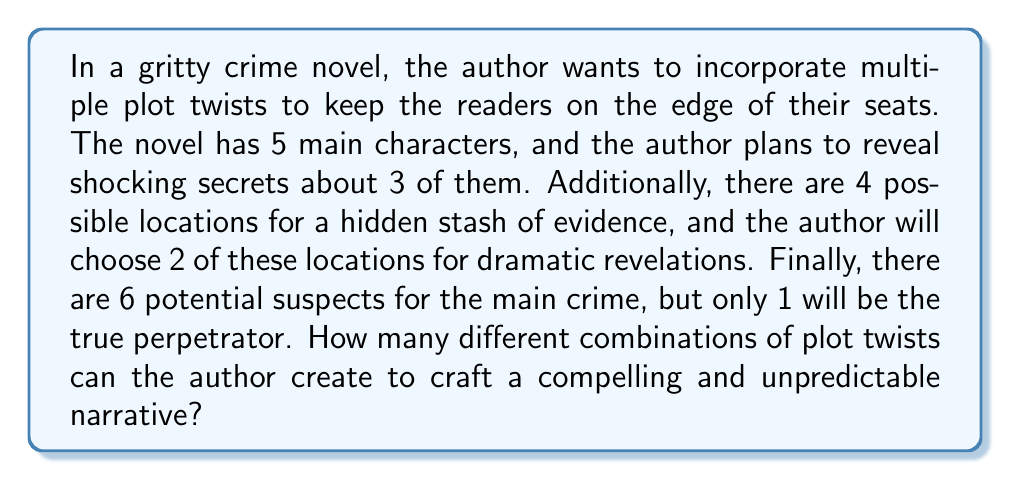What is the answer to this math problem? To solve this problem, we need to break it down into three separate combinatorial choices and then apply the multiplication principle.

1. Choosing characters for shocking secrets:
   We need to select 3 characters out of 5 for shocking revelations. This is a combination problem, represented as $\binom{5}{3}$.
   $$\binom{5}{3} = \frac{5!}{3!(5-3)!} = \frac{5!}{3!2!} = 10$$

2. Selecting locations for hidden evidence:
   We need to choose 2 locations out of 4 possible ones. This is another combination, $\binom{4}{2}$.
   $$\binom{4}{2} = \frac{4!}{2!(4-2)!} = \frac{4!}{2!2!} = 6$$

3. Choosing the true perpetrator:
   We need to select 1 suspect out of 6. This is a simple choice with 6 options.

Now, we apply the multiplication principle. The total number of possible plot twist combinations is the product of these three choices:

$$10 \times 6 \times 6 = 360$$

Therefore, the author has 360 different ways to combine these plot elements to create a unique set of twists in the crime novel.
Answer: 360 possible combinations of plot twists 